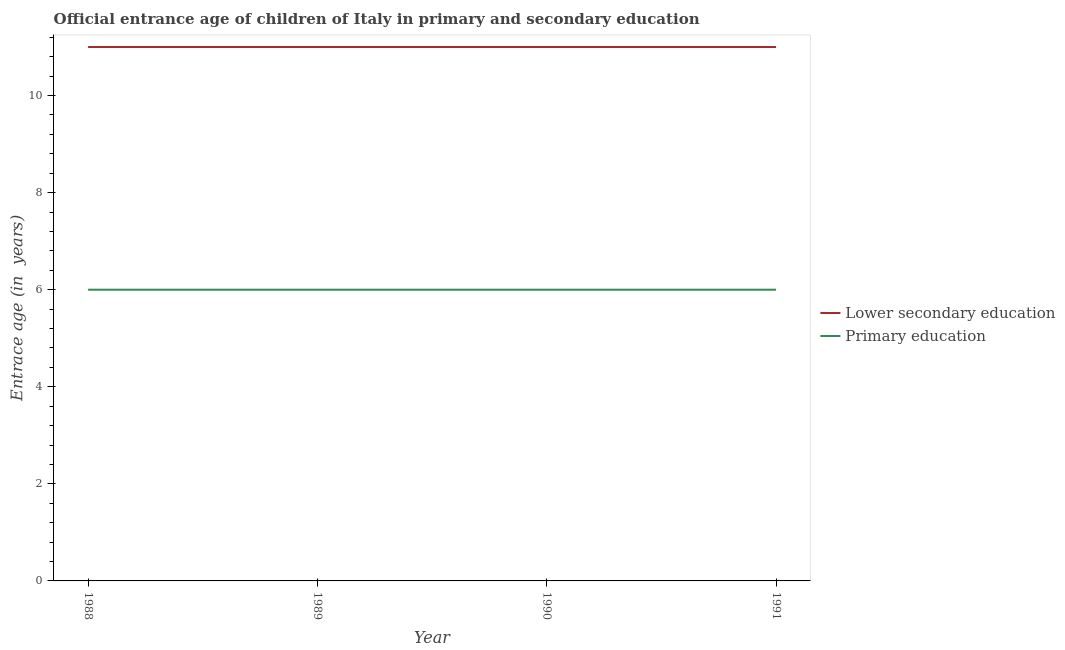How many different coloured lines are there?
Provide a succinct answer. 2. What is the entrance age of children in lower secondary education in 1988?
Provide a succinct answer. 11. Across all years, what is the maximum entrance age of children in lower secondary education?
Your answer should be very brief. 11. In which year was the entrance age of children in lower secondary education maximum?
Give a very brief answer. 1988. What is the total entrance age of children in lower secondary education in the graph?
Your response must be concise. 44. What is the difference between the entrance age of chiildren in primary education in 1989 and that in 1991?
Offer a terse response. 0. What is the difference between the entrance age of chiildren in primary education in 1989 and the entrance age of children in lower secondary education in 1991?
Your response must be concise. -5. In the year 1991, what is the difference between the entrance age of children in lower secondary education and entrance age of chiildren in primary education?
Your answer should be compact. 5. Is the entrance age of children in lower secondary education in 1989 less than that in 1990?
Your response must be concise. No. What is the difference between the highest and the second highest entrance age of chiildren in primary education?
Offer a terse response. 0. Is the sum of the entrance age of chiildren in primary education in 1989 and 1991 greater than the maximum entrance age of children in lower secondary education across all years?
Your answer should be very brief. Yes. Does the entrance age of children in lower secondary education monotonically increase over the years?
Offer a terse response. No. Is the entrance age of children in lower secondary education strictly greater than the entrance age of chiildren in primary education over the years?
Keep it short and to the point. Yes. Is the entrance age of chiildren in primary education strictly less than the entrance age of children in lower secondary education over the years?
Your response must be concise. Yes. What is the difference between two consecutive major ticks on the Y-axis?
Make the answer very short. 2. Are the values on the major ticks of Y-axis written in scientific E-notation?
Give a very brief answer. No. Does the graph contain any zero values?
Ensure brevity in your answer.  No. Where does the legend appear in the graph?
Ensure brevity in your answer.  Center right. What is the title of the graph?
Offer a terse response. Official entrance age of children of Italy in primary and secondary education. What is the label or title of the Y-axis?
Give a very brief answer. Entrace age (in  years). What is the Entrace age (in  years) in Lower secondary education in 1988?
Offer a very short reply. 11. What is the Entrace age (in  years) of Primary education in 1988?
Make the answer very short. 6. What is the Entrace age (in  years) in Lower secondary education in 1989?
Make the answer very short. 11. What is the Entrace age (in  years) in Primary education in 1990?
Provide a short and direct response. 6. Across all years, what is the minimum Entrace age (in  years) of Lower secondary education?
Offer a terse response. 11. What is the total Entrace age (in  years) of Primary education in the graph?
Your answer should be compact. 24. What is the difference between the Entrace age (in  years) of Primary education in 1988 and that in 1989?
Your answer should be very brief. 0. What is the difference between the Entrace age (in  years) of Lower secondary education in 1989 and that in 1991?
Ensure brevity in your answer.  0. What is the difference between the Entrace age (in  years) of Primary education in 1989 and that in 1991?
Your response must be concise. 0. What is the difference between the Entrace age (in  years) in Lower secondary education in 1988 and the Entrace age (in  years) in Primary education in 1990?
Ensure brevity in your answer.  5. What is the difference between the Entrace age (in  years) of Lower secondary education in 1988 and the Entrace age (in  years) of Primary education in 1991?
Your answer should be compact. 5. What is the average Entrace age (in  years) of Lower secondary education per year?
Your response must be concise. 11. In the year 1988, what is the difference between the Entrace age (in  years) in Lower secondary education and Entrace age (in  years) in Primary education?
Provide a short and direct response. 5. What is the ratio of the Entrace age (in  years) in Primary education in 1988 to that in 1989?
Your response must be concise. 1. What is the ratio of the Entrace age (in  years) of Lower secondary education in 1988 to that in 1990?
Provide a succinct answer. 1. What is the ratio of the Entrace age (in  years) of Primary education in 1988 to that in 1990?
Ensure brevity in your answer.  1. What is the ratio of the Entrace age (in  years) in Lower secondary education in 1988 to that in 1991?
Give a very brief answer. 1. What is the ratio of the Entrace age (in  years) of Primary education in 1988 to that in 1991?
Your answer should be very brief. 1. What is the ratio of the Entrace age (in  years) of Primary education in 1989 to that in 1990?
Give a very brief answer. 1. What is the ratio of the Entrace age (in  years) of Primary education in 1989 to that in 1991?
Your response must be concise. 1. What is the ratio of the Entrace age (in  years) in Lower secondary education in 1990 to that in 1991?
Give a very brief answer. 1. What is the ratio of the Entrace age (in  years) of Primary education in 1990 to that in 1991?
Your answer should be compact. 1. What is the difference between the highest and the second highest Entrace age (in  years) in Lower secondary education?
Keep it short and to the point. 0. What is the difference between the highest and the second highest Entrace age (in  years) of Primary education?
Offer a terse response. 0. What is the difference between the highest and the lowest Entrace age (in  years) in Primary education?
Make the answer very short. 0. 